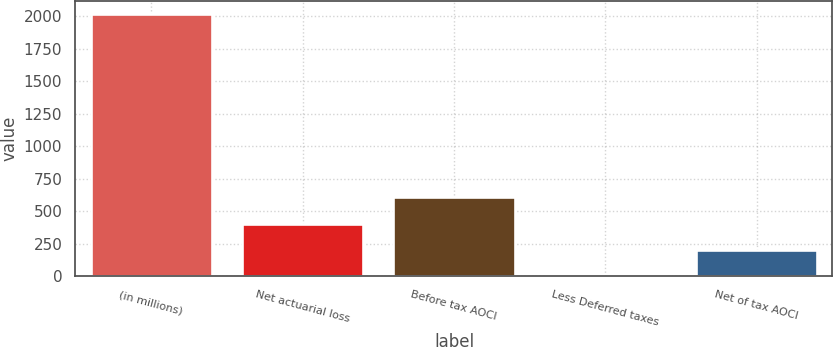Convert chart to OTSL. <chart><loc_0><loc_0><loc_500><loc_500><bar_chart><fcel>(in millions)<fcel>Net actuarial loss<fcel>Before tax AOCI<fcel>Less Deferred taxes<fcel>Net of tax AOCI<nl><fcel>2016<fcel>404.24<fcel>605.71<fcel>1.3<fcel>202.77<nl></chart> 